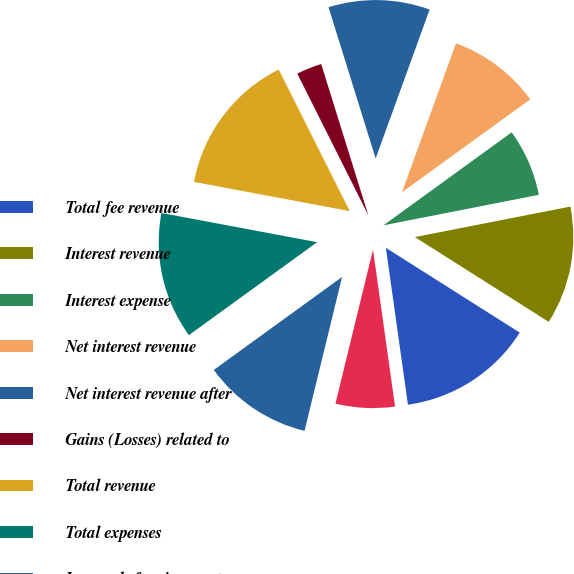Convert chart. <chart><loc_0><loc_0><loc_500><loc_500><pie_chart><fcel>Total fee revenue<fcel>Interest revenue<fcel>Interest expense<fcel>Net interest revenue<fcel>Net interest revenue after<fcel>Gains (Losses) related to<fcel>Total revenue<fcel>Total expenses<fcel>Income before income tax<fcel>Income tax expense<nl><fcel>13.79%<fcel>12.07%<fcel>6.9%<fcel>9.48%<fcel>10.34%<fcel>2.59%<fcel>14.65%<fcel>12.93%<fcel>11.21%<fcel>6.03%<nl></chart> 